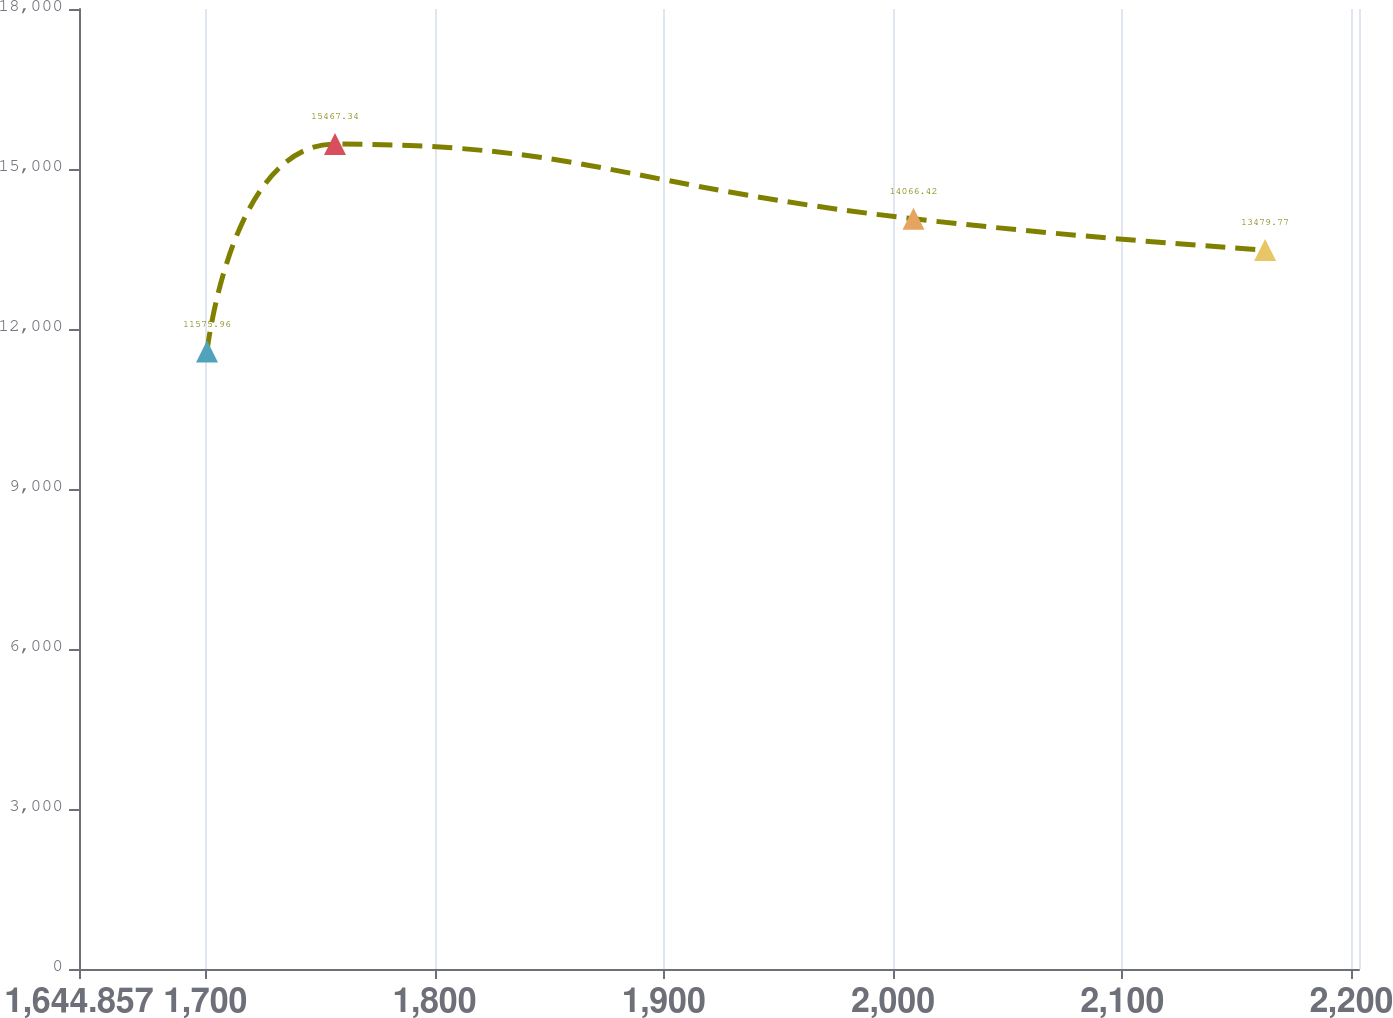Convert chart. <chart><loc_0><loc_0><loc_500><loc_500><line_chart><ecel><fcel>Unnamed: 1<nl><fcel>1700.7<fcel>11576<nl><fcel>1756.54<fcel>15467.3<nl><fcel>2008.94<fcel>14066.4<nl><fcel>2162.32<fcel>13479.8<nl><fcel>2259.13<fcel>12942.9<nl></chart> 